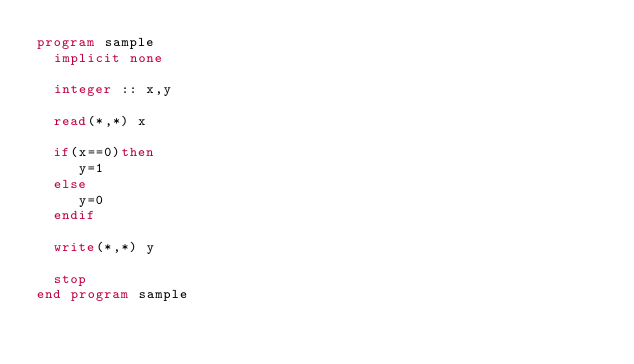Convert code to text. <code><loc_0><loc_0><loc_500><loc_500><_FORTRAN_>program sample
  implicit none

  integer :: x,y

  read(*,*) x

  if(x==0)then
     y=1
  else
     y=0
  endif

  write(*,*) y
  
  stop
end program sample</code> 